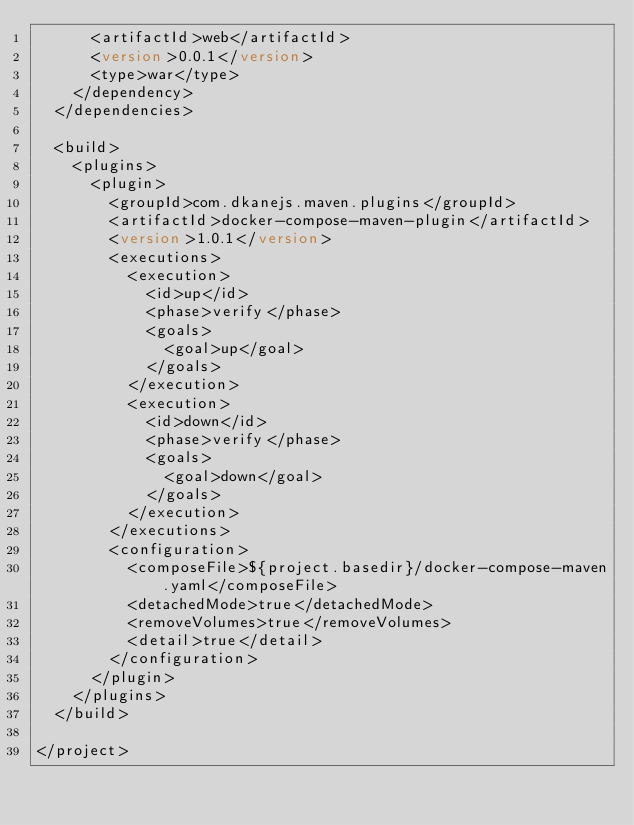<code> <loc_0><loc_0><loc_500><loc_500><_XML_>      <artifactId>web</artifactId>
      <version>0.0.1</version>
      <type>war</type>
    </dependency>
  </dependencies>

  <build>
    <plugins>
      <plugin>
        <groupId>com.dkanejs.maven.plugins</groupId>
        <artifactId>docker-compose-maven-plugin</artifactId>
        <version>1.0.1</version>
        <executions>
          <execution>
            <id>up</id>
            <phase>verify</phase>
            <goals>
              <goal>up</goal>
            </goals>
          </execution>
          <execution>
            <id>down</id>
            <phase>verify</phase>
            <goals>
              <goal>down</goal>
            </goals>
          </execution>
        </executions>
        <configuration>
          <composeFile>${project.basedir}/docker-compose-maven.yaml</composeFile>
          <detachedMode>true</detachedMode>
          <removeVolumes>true</removeVolumes>
          <detail>true</detail>
        </configuration>
      </plugin>
    </plugins>
  </build>

</project>
</code> 